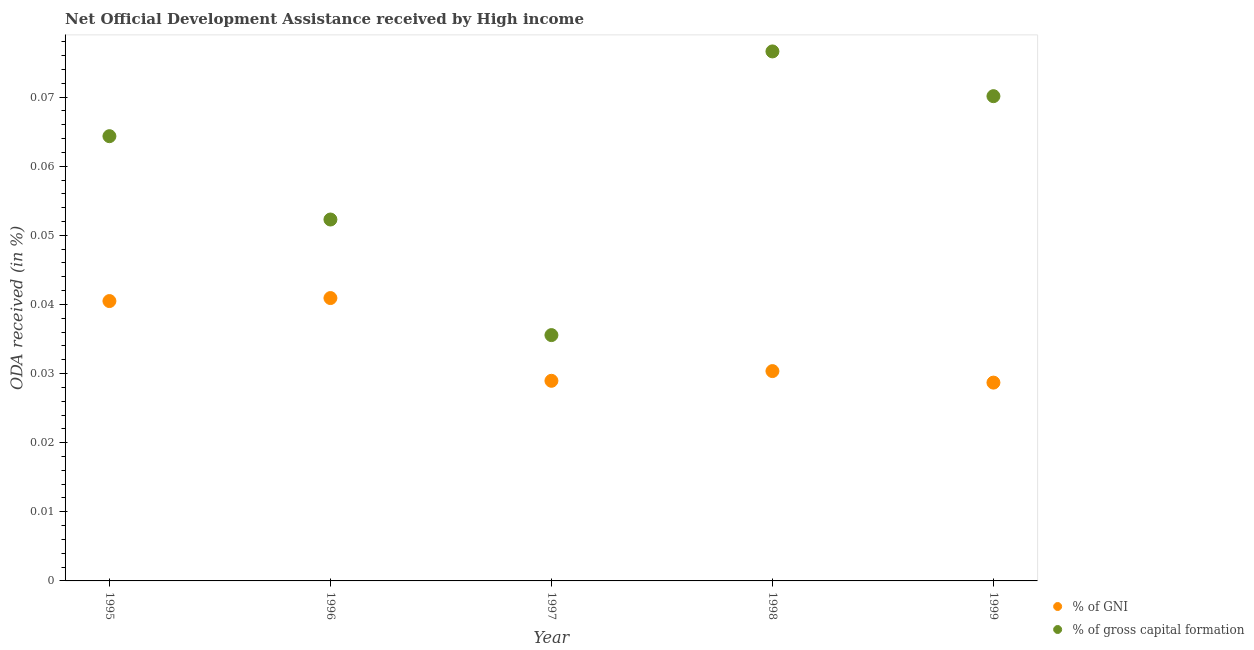How many different coloured dotlines are there?
Keep it short and to the point. 2. What is the oda received as percentage of gross capital formation in 1999?
Offer a terse response. 0.07. Across all years, what is the maximum oda received as percentage of gni?
Keep it short and to the point. 0.04. Across all years, what is the minimum oda received as percentage of gni?
Provide a short and direct response. 0.03. What is the total oda received as percentage of gni in the graph?
Offer a terse response. 0.17. What is the difference between the oda received as percentage of gross capital formation in 1997 and that in 1998?
Make the answer very short. -0.04. What is the difference between the oda received as percentage of gross capital formation in 1999 and the oda received as percentage of gni in 1998?
Ensure brevity in your answer.  0.04. What is the average oda received as percentage of gni per year?
Make the answer very short. 0.03. In the year 1997, what is the difference between the oda received as percentage of gni and oda received as percentage of gross capital formation?
Your answer should be compact. -0.01. In how many years, is the oda received as percentage of gross capital formation greater than 0.034 %?
Ensure brevity in your answer.  5. What is the ratio of the oda received as percentage of gni in 1996 to that in 1998?
Make the answer very short. 1.35. Is the oda received as percentage of gni in 1995 less than that in 1999?
Your answer should be very brief. No. Is the difference between the oda received as percentage of gross capital formation in 1998 and 1999 greater than the difference between the oda received as percentage of gni in 1998 and 1999?
Keep it short and to the point. Yes. What is the difference between the highest and the second highest oda received as percentage of gross capital formation?
Keep it short and to the point. 0.01. What is the difference between the highest and the lowest oda received as percentage of gni?
Your answer should be compact. 0.01. In how many years, is the oda received as percentage of gross capital formation greater than the average oda received as percentage of gross capital formation taken over all years?
Give a very brief answer. 3. Is the sum of the oda received as percentage of gni in 1995 and 1999 greater than the maximum oda received as percentage of gross capital formation across all years?
Provide a succinct answer. No. Is the oda received as percentage of gross capital formation strictly greater than the oda received as percentage of gni over the years?
Keep it short and to the point. Yes. How many dotlines are there?
Keep it short and to the point. 2. How many years are there in the graph?
Give a very brief answer. 5. Are the values on the major ticks of Y-axis written in scientific E-notation?
Offer a very short reply. No. Does the graph contain any zero values?
Provide a succinct answer. No. What is the title of the graph?
Provide a short and direct response. Net Official Development Assistance received by High income. Does "Electricity and heat production" appear as one of the legend labels in the graph?
Offer a terse response. No. What is the label or title of the X-axis?
Provide a short and direct response. Year. What is the label or title of the Y-axis?
Your answer should be compact. ODA received (in %). What is the ODA received (in %) in % of GNI in 1995?
Provide a short and direct response. 0.04. What is the ODA received (in %) of % of gross capital formation in 1995?
Your response must be concise. 0.06. What is the ODA received (in %) in % of GNI in 1996?
Your answer should be compact. 0.04. What is the ODA received (in %) of % of gross capital formation in 1996?
Ensure brevity in your answer.  0.05. What is the ODA received (in %) in % of GNI in 1997?
Keep it short and to the point. 0.03. What is the ODA received (in %) of % of gross capital formation in 1997?
Offer a terse response. 0.04. What is the ODA received (in %) in % of GNI in 1998?
Offer a terse response. 0.03. What is the ODA received (in %) of % of gross capital formation in 1998?
Offer a terse response. 0.08. What is the ODA received (in %) in % of GNI in 1999?
Offer a very short reply. 0.03. What is the ODA received (in %) of % of gross capital formation in 1999?
Provide a succinct answer. 0.07. Across all years, what is the maximum ODA received (in %) in % of GNI?
Your answer should be compact. 0.04. Across all years, what is the maximum ODA received (in %) of % of gross capital formation?
Provide a succinct answer. 0.08. Across all years, what is the minimum ODA received (in %) in % of GNI?
Ensure brevity in your answer.  0.03. Across all years, what is the minimum ODA received (in %) of % of gross capital formation?
Provide a succinct answer. 0.04. What is the total ODA received (in %) in % of GNI in the graph?
Keep it short and to the point. 0.17. What is the total ODA received (in %) of % of gross capital formation in the graph?
Give a very brief answer. 0.3. What is the difference between the ODA received (in %) of % of GNI in 1995 and that in 1996?
Offer a very short reply. -0. What is the difference between the ODA received (in %) in % of gross capital formation in 1995 and that in 1996?
Your answer should be compact. 0.01. What is the difference between the ODA received (in %) in % of GNI in 1995 and that in 1997?
Ensure brevity in your answer.  0.01. What is the difference between the ODA received (in %) of % of gross capital formation in 1995 and that in 1997?
Offer a very short reply. 0.03. What is the difference between the ODA received (in %) of % of GNI in 1995 and that in 1998?
Your answer should be very brief. 0.01. What is the difference between the ODA received (in %) in % of gross capital formation in 1995 and that in 1998?
Keep it short and to the point. -0.01. What is the difference between the ODA received (in %) of % of GNI in 1995 and that in 1999?
Ensure brevity in your answer.  0.01. What is the difference between the ODA received (in %) of % of gross capital formation in 1995 and that in 1999?
Provide a succinct answer. -0.01. What is the difference between the ODA received (in %) of % of GNI in 1996 and that in 1997?
Your answer should be very brief. 0.01. What is the difference between the ODA received (in %) in % of gross capital formation in 1996 and that in 1997?
Make the answer very short. 0.02. What is the difference between the ODA received (in %) in % of GNI in 1996 and that in 1998?
Ensure brevity in your answer.  0.01. What is the difference between the ODA received (in %) in % of gross capital formation in 1996 and that in 1998?
Offer a terse response. -0.02. What is the difference between the ODA received (in %) in % of GNI in 1996 and that in 1999?
Ensure brevity in your answer.  0.01. What is the difference between the ODA received (in %) in % of gross capital formation in 1996 and that in 1999?
Provide a short and direct response. -0.02. What is the difference between the ODA received (in %) of % of GNI in 1997 and that in 1998?
Keep it short and to the point. -0. What is the difference between the ODA received (in %) of % of gross capital formation in 1997 and that in 1998?
Provide a short and direct response. -0.04. What is the difference between the ODA received (in %) in % of gross capital formation in 1997 and that in 1999?
Your answer should be very brief. -0.03. What is the difference between the ODA received (in %) in % of GNI in 1998 and that in 1999?
Your answer should be very brief. 0. What is the difference between the ODA received (in %) of % of gross capital formation in 1998 and that in 1999?
Offer a very short reply. 0.01. What is the difference between the ODA received (in %) in % of GNI in 1995 and the ODA received (in %) in % of gross capital formation in 1996?
Offer a terse response. -0.01. What is the difference between the ODA received (in %) in % of GNI in 1995 and the ODA received (in %) in % of gross capital formation in 1997?
Your answer should be compact. 0. What is the difference between the ODA received (in %) of % of GNI in 1995 and the ODA received (in %) of % of gross capital formation in 1998?
Your answer should be very brief. -0.04. What is the difference between the ODA received (in %) of % of GNI in 1995 and the ODA received (in %) of % of gross capital formation in 1999?
Provide a succinct answer. -0.03. What is the difference between the ODA received (in %) of % of GNI in 1996 and the ODA received (in %) of % of gross capital formation in 1997?
Your response must be concise. 0.01. What is the difference between the ODA received (in %) of % of GNI in 1996 and the ODA received (in %) of % of gross capital formation in 1998?
Offer a very short reply. -0.04. What is the difference between the ODA received (in %) in % of GNI in 1996 and the ODA received (in %) in % of gross capital formation in 1999?
Offer a terse response. -0.03. What is the difference between the ODA received (in %) of % of GNI in 1997 and the ODA received (in %) of % of gross capital formation in 1998?
Your answer should be very brief. -0.05. What is the difference between the ODA received (in %) in % of GNI in 1997 and the ODA received (in %) in % of gross capital formation in 1999?
Your response must be concise. -0.04. What is the difference between the ODA received (in %) of % of GNI in 1998 and the ODA received (in %) of % of gross capital formation in 1999?
Your answer should be compact. -0.04. What is the average ODA received (in %) of % of GNI per year?
Give a very brief answer. 0.03. What is the average ODA received (in %) of % of gross capital formation per year?
Keep it short and to the point. 0.06. In the year 1995, what is the difference between the ODA received (in %) of % of GNI and ODA received (in %) of % of gross capital formation?
Your answer should be compact. -0.02. In the year 1996, what is the difference between the ODA received (in %) of % of GNI and ODA received (in %) of % of gross capital formation?
Give a very brief answer. -0.01. In the year 1997, what is the difference between the ODA received (in %) of % of GNI and ODA received (in %) of % of gross capital formation?
Your answer should be compact. -0.01. In the year 1998, what is the difference between the ODA received (in %) of % of GNI and ODA received (in %) of % of gross capital formation?
Offer a very short reply. -0.05. In the year 1999, what is the difference between the ODA received (in %) of % of GNI and ODA received (in %) of % of gross capital formation?
Offer a terse response. -0.04. What is the ratio of the ODA received (in %) of % of GNI in 1995 to that in 1996?
Your answer should be compact. 0.99. What is the ratio of the ODA received (in %) of % of gross capital formation in 1995 to that in 1996?
Give a very brief answer. 1.23. What is the ratio of the ODA received (in %) of % of GNI in 1995 to that in 1997?
Give a very brief answer. 1.4. What is the ratio of the ODA received (in %) in % of gross capital formation in 1995 to that in 1997?
Make the answer very short. 1.81. What is the ratio of the ODA received (in %) of % of GNI in 1995 to that in 1998?
Keep it short and to the point. 1.33. What is the ratio of the ODA received (in %) in % of gross capital formation in 1995 to that in 1998?
Your response must be concise. 0.84. What is the ratio of the ODA received (in %) in % of GNI in 1995 to that in 1999?
Your answer should be compact. 1.41. What is the ratio of the ODA received (in %) of % of gross capital formation in 1995 to that in 1999?
Give a very brief answer. 0.92. What is the ratio of the ODA received (in %) of % of GNI in 1996 to that in 1997?
Give a very brief answer. 1.41. What is the ratio of the ODA received (in %) in % of gross capital formation in 1996 to that in 1997?
Keep it short and to the point. 1.47. What is the ratio of the ODA received (in %) of % of GNI in 1996 to that in 1998?
Your answer should be very brief. 1.35. What is the ratio of the ODA received (in %) of % of gross capital formation in 1996 to that in 1998?
Your answer should be very brief. 0.68. What is the ratio of the ODA received (in %) in % of GNI in 1996 to that in 1999?
Offer a terse response. 1.43. What is the ratio of the ODA received (in %) of % of gross capital formation in 1996 to that in 1999?
Ensure brevity in your answer.  0.75. What is the ratio of the ODA received (in %) of % of GNI in 1997 to that in 1998?
Ensure brevity in your answer.  0.95. What is the ratio of the ODA received (in %) of % of gross capital formation in 1997 to that in 1998?
Provide a short and direct response. 0.46. What is the ratio of the ODA received (in %) in % of GNI in 1997 to that in 1999?
Give a very brief answer. 1.01. What is the ratio of the ODA received (in %) of % of gross capital formation in 1997 to that in 1999?
Provide a short and direct response. 0.51. What is the ratio of the ODA received (in %) in % of GNI in 1998 to that in 1999?
Your answer should be compact. 1.06. What is the ratio of the ODA received (in %) of % of gross capital formation in 1998 to that in 1999?
Ensure brevity in your answer.  1.09. What is the difference between the highest and the second highest ODA received (in %) of % of gross capital formation?
Your response must be concise. 0.01. What is the difference between the highest and the lowest ODA received (in %) of % of GNI?
Your response must be concise. 0.01. What is the difference between the highest and the lowest ODA received (in %) in % of gross capital formation?
Your response must be concise. 0.04. 